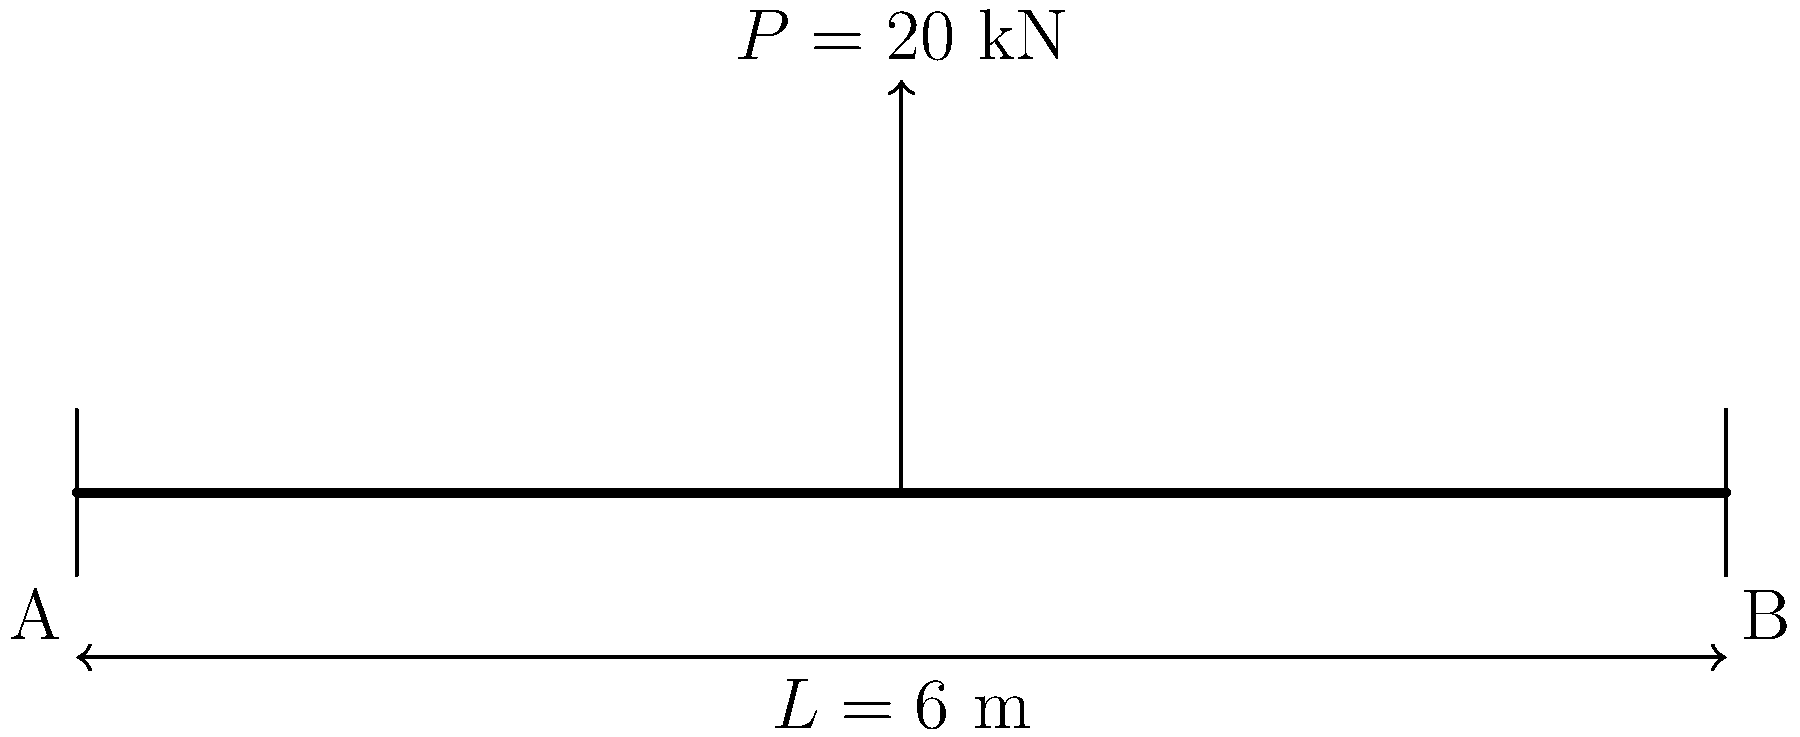Robert, remember when we discussed beam analysis at the Stevenson family barbecue? Here's a follow-up question: A simply supported beam of length $L = 6$ m is subjected to a point load $P = 20$ kN at its midspan. Calculate the maximum bending moment in the beam. Let's approach this step-by-step, Robert:

1) For a simply supported beam with a point load at the center, the reactions at both supports will be equal:
   $R_A = R_B = \frac{P}{2} = \frac{20}{2} = 10$ kN

2) The maximum bending moment occurs at the point of load application (midspan).

3) We can calculate this using the formula:
   $M_{max} = \frac{PL}{4}$

   Where:
   $P = 20$ kN (given point load)
   $L = 6$ m (beam length)

4) Substituting these values:
   $M_{max} = \frac{20 \times 6}{4} = \frac{120}{4} = 30$ kN·m

Therefore, the maximum bending moment in the beam is 30 kN·m.
Answer: 30 kN·m 